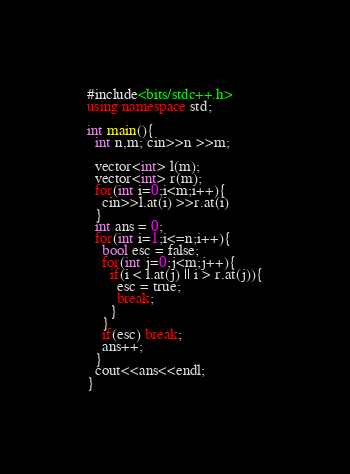Convert code to text. <code><loc_0><loc_0><loc_500><loc_500><_C++_>#include<bits/stdc++.h>
using namespace std;

int main(){
  int n,m; cin>>n >>m;

  vector<int> l(m);
  vector<int> r(m);
  for(int i=0;i<m;i++){
    cin>>l.at(i) >>r.at(i)
  }
  int ans = 0;
  for(int i=1;i<=n;i++){
    bool esc = false;
    for(int j=0;j<m;j++){
      if(i < l.at(j) || i > r.at(j)){
        esc = true;
        break;
      }
    }
    if(esc) break;
    ans++;
  }
  cout<<ans<<endl;
}</code> 